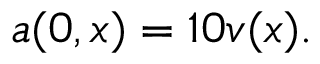<formula> <loc_0><loc_0><loc_500><loc_500>a ( 0 , x ) = 1 0 v ( x ) .</formula> 